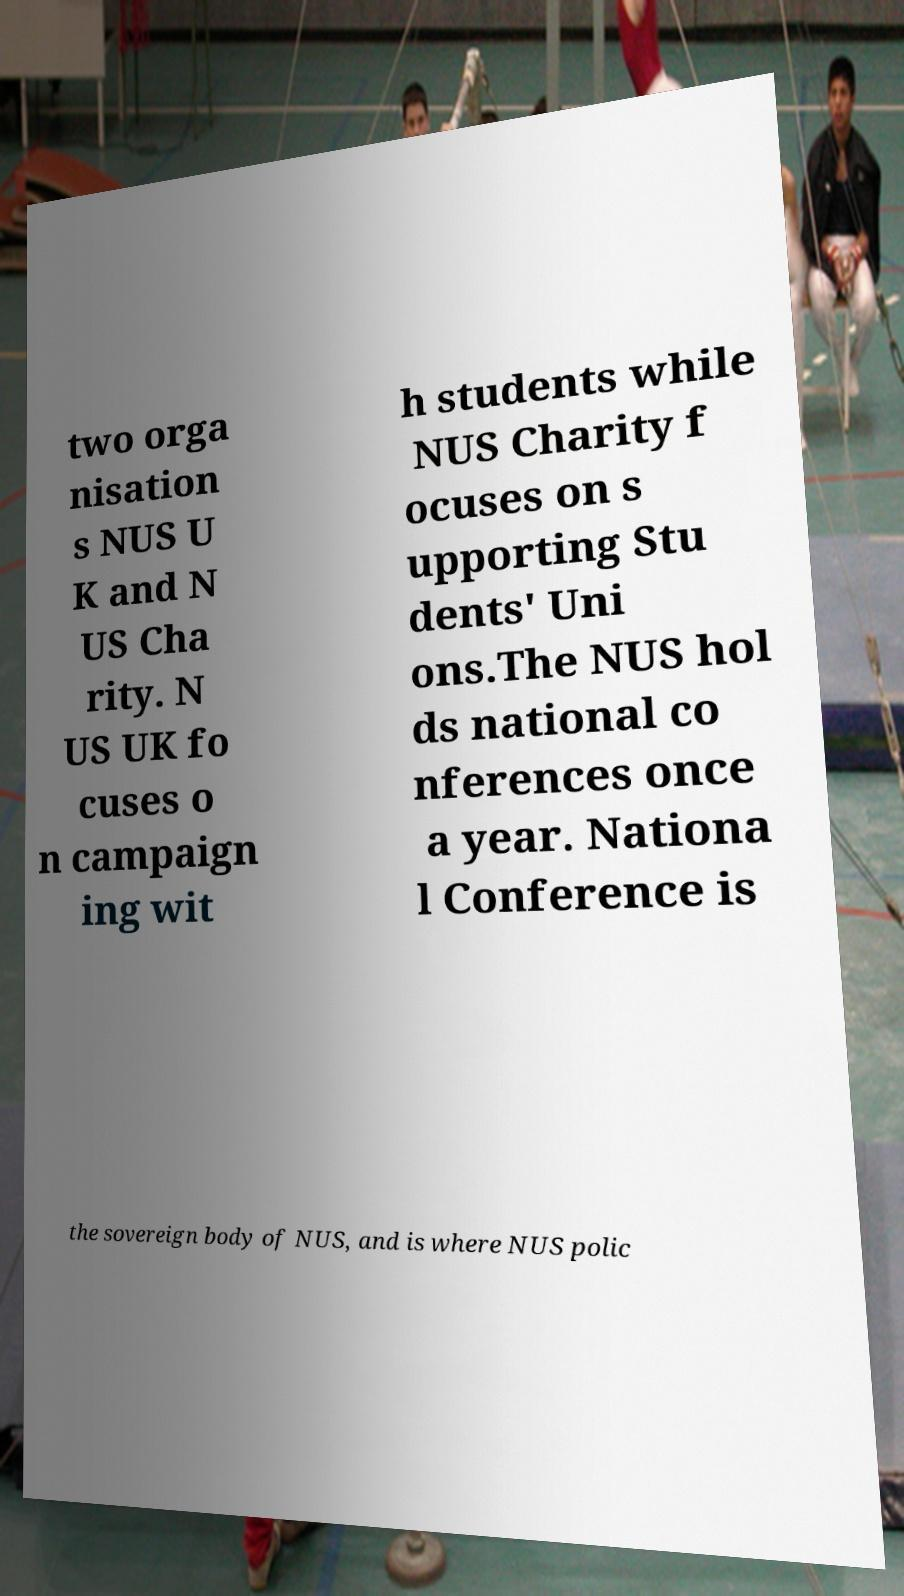For documentation purposes, I need the text within this image transcribed. Could you provide that? two orga nisation s NUS U K and N US Cha rity. N US UK fo cuses o n campaign ing wit h students while NUS Charity f ocuses on s upporting Stu dents' Uni ons.The NUS hol ds national co nferences once a year. Nationa l Conference is the sovereign body of NUS, and is where NUS polic 